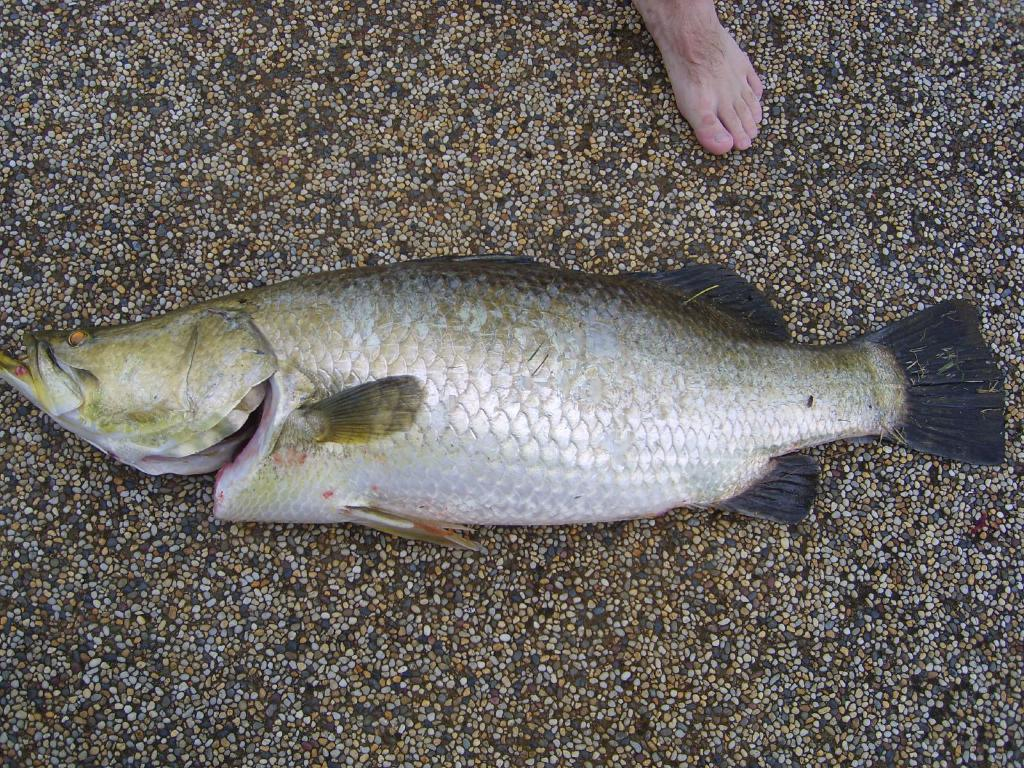What is the main subject in the middle of the image? There is a fish in the middle of the image. What part of a person can be seen at the top of the image? There is a person's leg at the top of the image. What type of natural elements are visible in the background of the image? There are stones in the background of the image. How many dolls are playing baseball in the image? There are no dolls or baseball activity present in the image. 